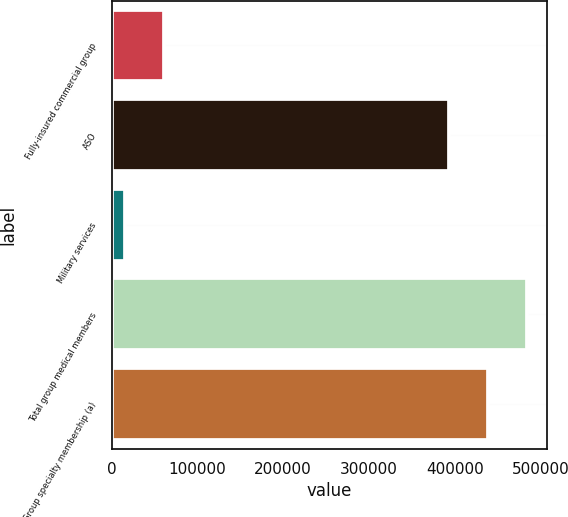<chart> <loc_0><loc_0><loc_500><loc_500><bar_chart><fcel>Fully-insured commercial group<fcel>ASO<fcel>Military services<fcel>Total group medical members<fcel>Group specialty membership (a)<nl><fcel>61080<fcel>393600<fcel>16000<fcel>483760<fcel>438680<nl></chart> 